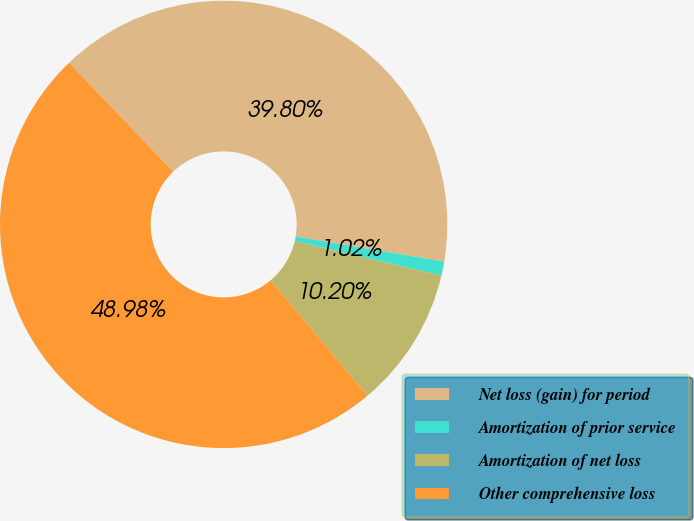Convert chart. <chart><loc_0><loc_0><loc_500><loc_500><pie_chart><fcel>Net loss (gain) for period<fcel>Amortization of prior service<fcel>Amortization of net loss<fcel>Other comprehensive loss<nl><fcel>39.8%<fcel>1.02%<fcel>10.2%<fcel>48.98%<nl></chart> 